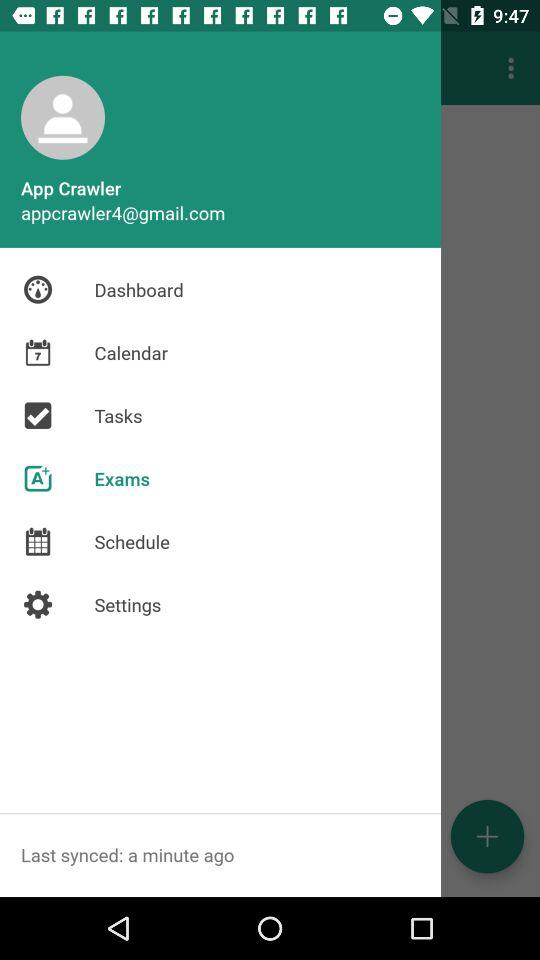What is the user name? The user name is App Crawler. 